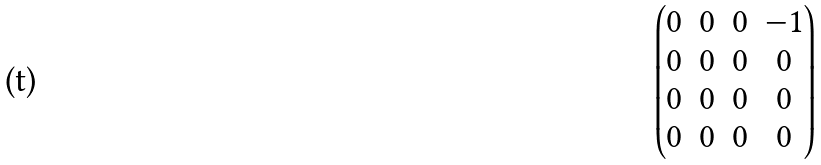<formula> <loc_0><loc_0><loc_500><loc_500>\begin{pmatrix} 0 & 0 & 0 & - 1 \\ 0 & 0 & 0 & 0 \\ 0 & 0 & 0 & 0 \\ 0 & 0 & 0 & 0 \end{pmatrix}</formula> 